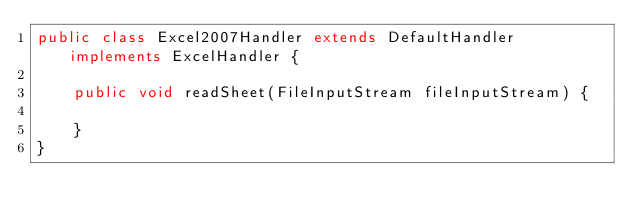<code> <loc_0><loc_0><loc_500><loc_500><_Java_>public class Excel2007Handler extends DefaultHandler implements ExcelHandler {

    public void readSheet(FileInputStream fileInputStream) {

    }
}
</code> 